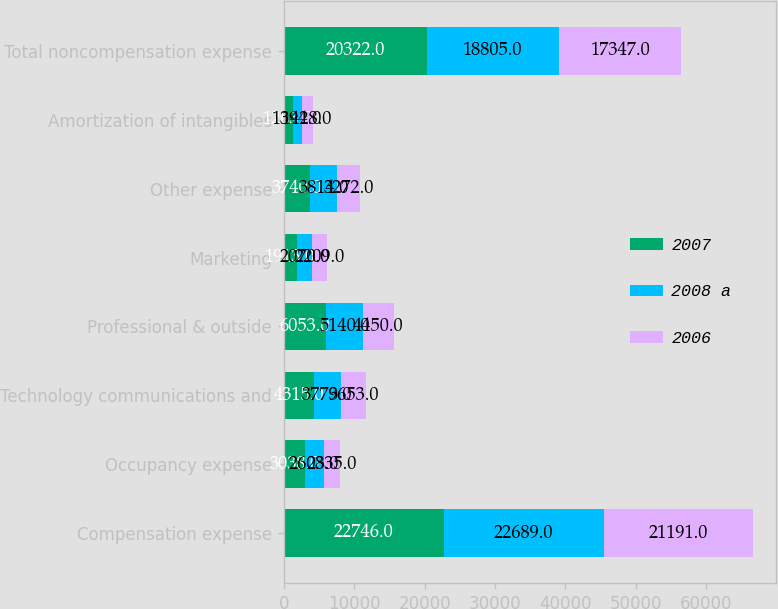Convert chart to OTSL. <chart><loc_0><loc_0><loc_500><loc_500><stacked_bar_chart><ecel><fcel>Compensation expense<fcel>Occupancy expense<fcel>Technology communications and<fcel>Professional & outside<fcel>Marketing<fcel>Other expense<fcel>Amortization of intangibles<fcel>Total noncompensation expense<nl><fcel>2007<fcel>22746<fcel>3038<fcel>4315<fcel>6053<fcel>1913<fcel>3740<fcel>1263<fcel>20322<nl><fcel>2008 a<fcel>22689<fcel>2608<fcel>3779<fcel>5140<fcel>2070<fcel>3814<fcel>1394<fcel>18805<nl><fcel>2006<fcel>21191<fcel>2335<fcel>3653<fcel>4450<fcel>2209<fcel>3272<fcel>1428<fcel>17347<nl></chart> 